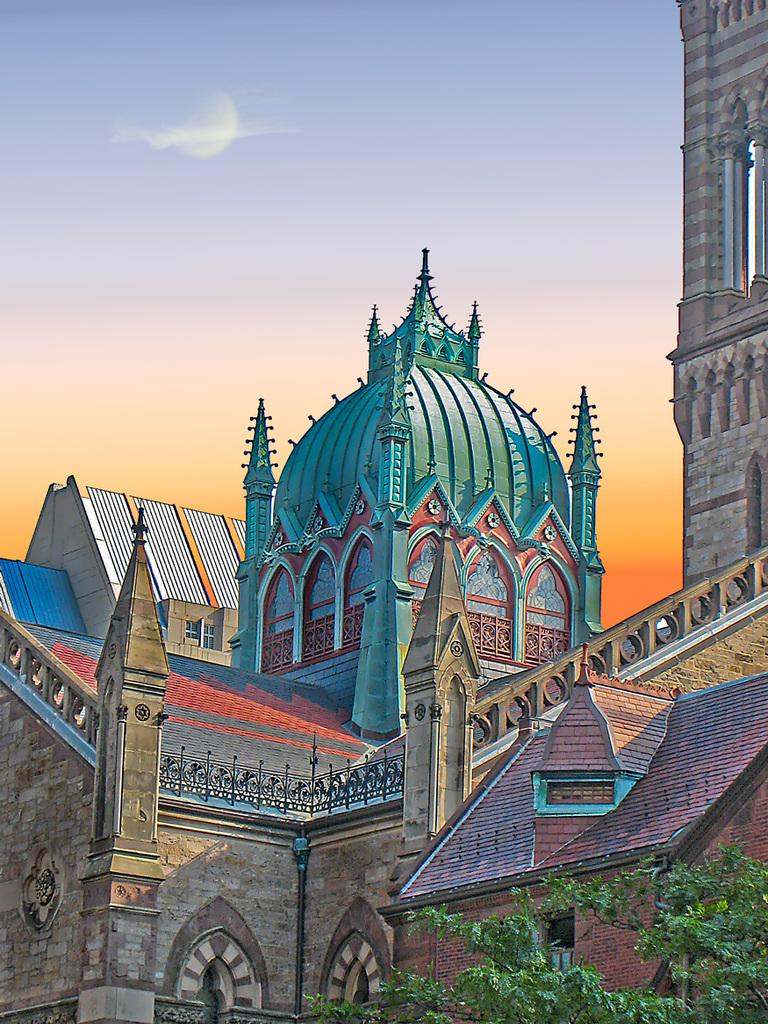What can be inferred about the image based on the fact that it appears to be edited? The image appears to be edited, which means it may have been altered or manipulated in some way. What type of structures can be seen in the image? There are buildings in the image. Where is the tree located in the image? The tree is in the bottom right corner of the image. What can be seen in the background of the image? The sky is visible in the background of the image. What type of smell can be detected from the kettle in the image? There is no kettle present in the image, so it is not possible to detect any smell. 